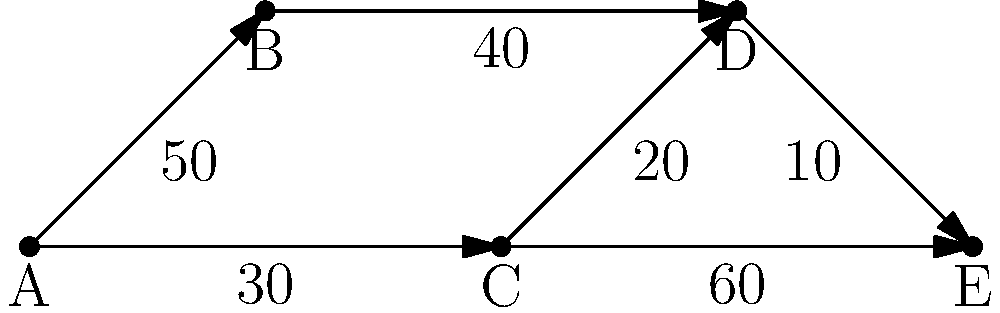In the directed graph representing refugee migration patterns, where each node represents a country and edge weights indicate the number of refugees (in thousands) moving between countries, what is the minimum number of refugees that must pass through intermediate countries to reach country E from country A? To solve this problem, we need to find the path with the minimum total number of refugees from country A to country E. Let's analyze the possible paths:

1. Path A → B → D → E:
   - A to B: 50,000 refugees
   - B to D: 40,000 refugees
   - D to E: 10,000 refugees
   Minimum number passing through intermediates: 40,000

2. Path A → C → D → E:
   - A to C: 30,000 refugees
   - C to D: 20,000 refugees
   - D to E: 10,000 refugees
   Minimum number passing through intermediates: 20,000

3. Path A → C → E:
   - A to C: 30,000 refugees
   - C to E: 60,000 refugees
   Minimum number passing through intermediates: 60,000

The path with the minimum number of refugees passing through intermediate countries is A → C → D → E, with 20,000 refugees (the number moving from C to D) being the minimum that must pass through an intermediate country.
Answer: 20,000 